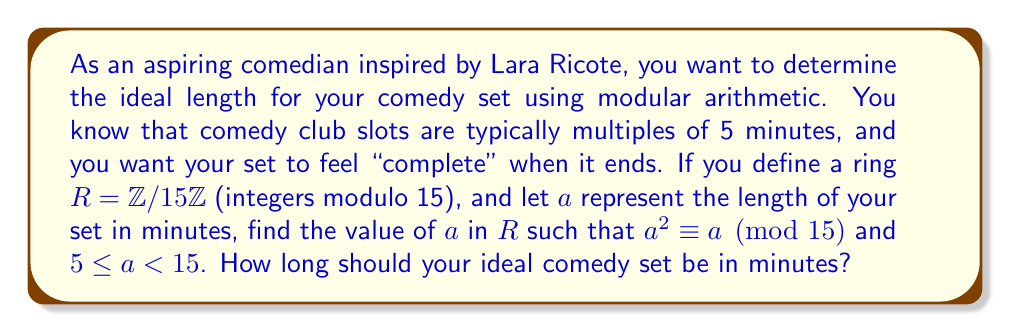Can you answer this question? Let's approach this step-by-step:

1) We're working in the ring $R = \mathbb{Z}/15\mathbb{Z}$, which means all our calculations will be modulo 15.

2) We need to find $a$ such that $a^2 \equiv a \pmod{15}$ and $5 \leq a < 15$.

3) Let's check each value of $a$ from 5 to 14:

   For $a = 5$: $5^2 = 25 \equiv 10 \pmod{15}$, which is not equivalent to 5.
   For $a = 6$: $6^2 = 36 \equiv 6 \pmod{15}$, which works!
   For $a = 7$: $7^2 = 49 \equiv 4 \pmod{15}$, which is not equivalent to 7.
   For $a = 8$: $8^2 = 64 \equiv 4 \pmod{15}$, which is not equivalent to 8.
   For $a = 9$: $9^2 = 81 \equiv 6 \pmod{15}$, which is not equivalent to 9.
   For $a = 10$: $10^2 = 100 \equiv 10 \pmod{15}$, which works!
   For $a = 11$: $11^2 = 121 \equiv 1 \pmod{15}$, which is not equivalent to 11.
   For $a = 12$: $12^2 = 144 \equiv 9 \pmod{15}$, which is not equivalent to 12.
   For $a = 13$: $13^2 = 169 \equiv 4 \pmod{15}$, which is not equivalent to 13.
   For $a = 14$: $14^2 = 196 \equiv 1 \pmod{15}$, which is not equivalent to 14.

4) We found two values that satisfy the condition: 6 and 10.

5) However, as an aspiring comedian, you'd likely prefer the longer set time to showcase more of your material.

Therefore, the ideal length for your comedy set is 10 minutes.
Answer: 10 minutes 